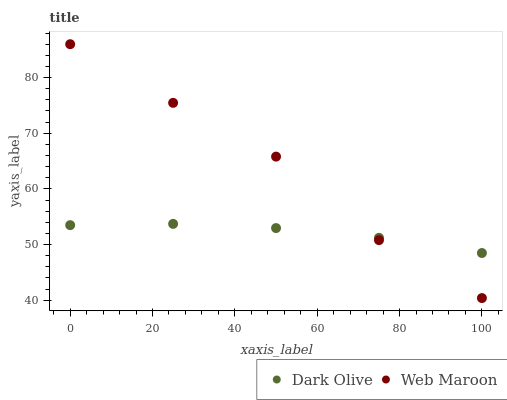Does Dark Olive have the minimum area under the curve?
Answer yes or no. Yes. Does Web Maroon have the maximum area under the curve?
Answer yes or no. Yes. Does Web Maroon have the minimum area under the curve?
Answer yes or no. No. Is Dark Olive the smoothest?
Answer yes or no. Yes. Is Web Maroon the roughest?
Answer yes or no. Yes. Is Web Maroon the smoothest?
Answer yes or no. No. Does Web Maroon have the lowest value?
Answer yes or no. Yes. Does Web Maroon have the highest value?
Answer yes or no. Yes. Does Web Maroon intersect Dark Olive?
Answer yes or no. Yes. Is Web Maroon less than Dark Olive?
Answer yes or no. No. Is Web Maroon greater than Dark Olive?
Answer yes or no. No. 